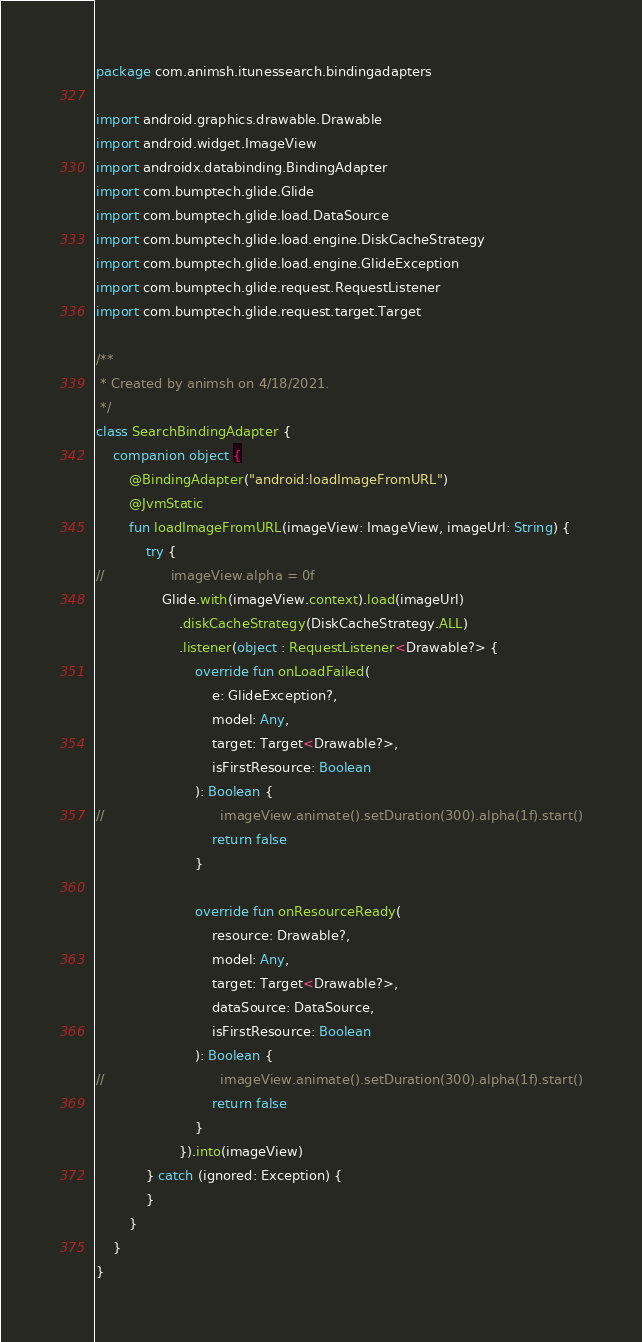<code> <loc_0><loc_0><loc_500><loc_500><_Kotlin_>package com.animsh.itunessearch.bindingadapters

import android.graphics.drawable.Drawable
import android.widget.ImageView
import androidx.databinding.BindingAdapter
import com.bumptech.glide.Glide
import com.bumptech.glide.load.DataSource
import com.bumptech.glide.load.engine.DiskCacheStrategy
import com.bumptech.glide.load.engine.GlideException
import com.bumptech.glide.request.RequestListener
import com.bumptech.glide.request.target.Target

/**
 * Created by animsh on 4/18/2021.
 */
class SearchBindingAdapter {
    companion object {
        @BindingAdapter("android:loadImageFromURL")
        @JvmStatic
        fun loadImageFromURL(imageView: ImageView, imageUrl: String) {
            try {
//                imageView.alpha = 0f
                Glide.with(imageView.context).load(imageUrl)
                    .diskCacheStrategy(DiskCacheStrategy.ALL)
                    .listener(object : RequestListener<Drawable?> {
                        override fun onLoadFailed(
                            e: GlideException?,
                            model: Any,
                            target: Target<Drawable?>,
                            isFirstResource: Boolean
                        ): Boolean {
//                            imageView.animate().setDuration(300).alpha(1f).start()
                            return false
                        }

                        override fun onResourceReady(
                            resource: Drawable?,
                            model: Any,
                            target: Target<Drawable?>,
                            dataSource: DataSource,
                            isFirstResource: Boolean
                        ): Boolean {
//                            imageView.animate().setDuration(300).alpha(1f).start()
                            return false
                        }
                    }).into(imageView)
            } catch (ignored: Exception) {
            }
        }
    }
}
</code> 